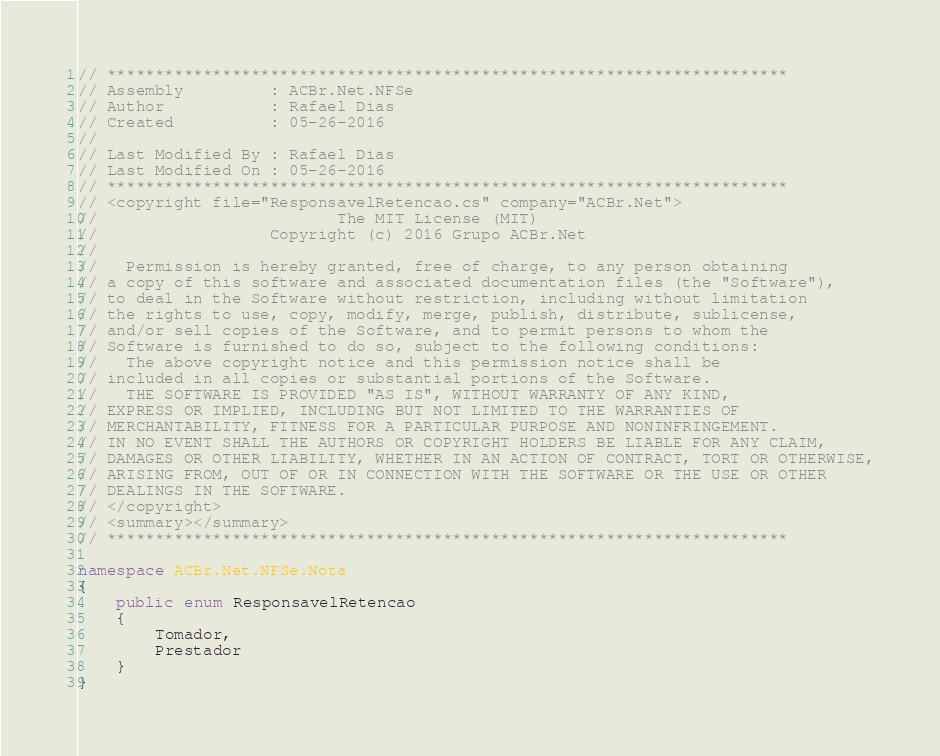<code> <loc_0><loc_0><loc_500><loc_500><_C#_>// ***********************************************************************
// Assembly         : ACBr.Net.NFSe
// Author           : Rafael Dias
// Created          : 05-26-2016
//
// Last Modified By : Rafael Dias
// Last Modified On : 05-26-2016
// ***********************************************************************
// <copyright file="ResponsavelRetencao.cs" company="ACBr.Net">
//		        		   The MIT License (MIT)
//	     		    Copyright (c) 2016 Grupo ACBr.Net
//
//	 Permission is hereby granted, free of charge, to any person obtaining
// a copy of this software and associated documentation files (the "Software"),
// to deal in the Software without restriction, including without limitation
// the rights to use, copy, modify, merge, publish, distribute, sublicense,
// and/or sell copies of the Software, and to permit persons to whom the
// Software is furnished to do so, subject to the following conditions:
//	 The above copyright notice and this permission notice shall be
// included in all copies or substantial portions of the Software.
//	 THE SOFTWARE IS PROVIDED "AS IS", WITHOUT WARRANTY OF ANY KIND,
// EXPRESS OR IMPLIED, INCLUDING BUT NOT LIMITED TO THE WARRANTIES OF
// MERCHANTABILITY, FITNESS FOR A PARTICULAR PURPOSE AND NONINFRINGEMENT.
// IN NO EVENT SHALL THE AUTHORS OR COPYRIGHT HOLDERS BE LIABLE FOR ANY CLAIM,
// DAMAGES OR OTHER LIABILITY, WHETHER IN AN ACTION OF CONTRACT, TORT OR OTHERWISE,
// ARISING FROM, OUT OF OR IN CONNECTION WITH THE SOFTWARE OR THE USE OR OTHER
// DEALINGS IN THE SOFTWARE.
// </copyright>
// <summary></summary>
// ***********************************************************************

namespace ACBr.Net.NFSe.Nota
{
    public enum ResponsavelRetencao
    {
        Tomador,
        Prestador
    }
}</code> 